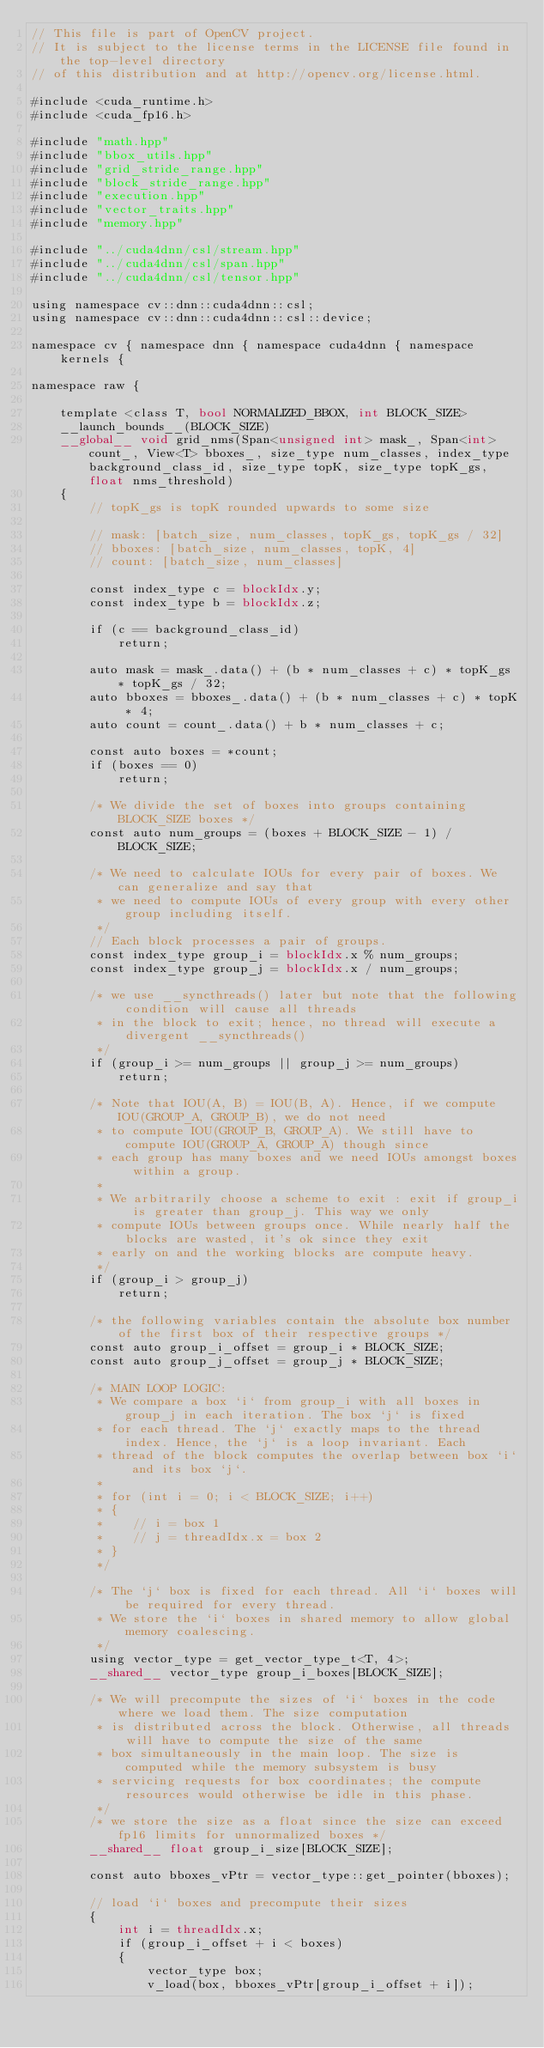Convert code to text. <code><loc_0><loc_0><loc_500><loc_500><_Cuda_>// This file is part of OpenCV project.
// It is subject to the license terms in the LICENSE file found in the top-level directory
// of this distribution and at http://opencv.org/license.html.

#include <cuda_runtime.h>
#include <cuda_fp16.h>

#include "math.hpp"
#include "bbox_utils.hpp"
#include "grid_stride_range.hpp"
#include "block_stride_range.hpp"
#include "execution.hpp"
#include "vector_traits.hpp"
#include "memory.hpp"

#include "../cuda4dnn/csl/stream.hpp"
#include "../cuda4dnn/csl/span.hpp"
#include "../cuda4dnn/csl/tensor.hpp"

using namespace cv::dnn::cuda4dnn::csl;
using namespace cv::dnn::cuda4dnn::csl::device;

namespace cv { namespace dnn { namespace cuda4dnn { namespace kernels {

namespace raw {

    template <class T, bool NORMALIZED_BBOX, int BLOCK_SIZE>
    __launch_bounds__(BLOCK_SIZE)
    __global__ void grid_nms(Span<unsigned int> mask_, Span<int> count_, View<T> bboxes_, size_type num_classes, index_type background_class_id, size_type topK, size_type topK_gs, float nms_threshold)
    {
        // topK_gs is topK rounded upwards to some size

        // mask: [batch_size, num_classes, topK_gs, topK_gs / 32]
        // bboxes: [batch_size, num_classes, topK, 4]
        // count: [batch_size, num_classes]

        const index_type c = blockIdx.y;
        const index_type b = blockIdx.z;

        if (c == background_class_id)
            return;

        auto mask = mask_.data() + (b * num_classes + c) * topK_gs * topK_gs / 32;
        auto bboxes = bboxes_.data() + (b * num_classes + c) * topK * 4;
        auto count = count_.data() + b * num_classes + c;

        const auto boxes = *count;
        if (boxes == 0)
            return;

        /* We divide the set of boxes into groups containing BLOCK_SIZE boxes */
        const auto num_groups = (boxes + BLOCK_SIZE - 1) / BLOCK_SIZE;

        /* We need to calculate IOUs for every pair of boxes. We can generalize and say that
         * we need to compute IOUs of every group with every other group including itself.
         */
        // Each block processes a pair of groups.
        const index_type group_i = blockIdx.x % num_groups;
        const index_type group_j = blockIdx.x / num_groups;

        /* we use __syncthreads() later but note that the following condition will cause all threads
         * in the block to exit; hence, no thread will execute a divergent __syncthreads()
         */
        if (group_i >= num_groups || group_j >= num_groups)
            return;

        /* Note that IOU(A, B) = IOU(B, A). Hence, if we compute IOU(GROUP_A, GROUP_B), we do not need
         * to compute IOU(GROUP_B, GROUP_A). We still have to compute IOU(GROUP_A, GROUP_A) though since
         * each group has many boxes and we need IOUs amongst boxes within a group.
         *
         * We arbitrarily choose a scheme to exit : exit if group_i is greater than group_j. This way we only
         * compute IOUs between groups once. While nearly half the blocks are wasted, it's ok since they exit
         * early on and the working blocks are compute heavy.
         */
        if (group_i > group_j)
            return;

        /* the following variables contain the absolute box number of the first box of their respective groups */
        const auto group_i_offset = group_i * BLOCK_SIZE;
        const auto group_j_offset = group_j * BLOCK_SIZE;

        /* MAIN LOOP LOGIC:
         * We compare a box `i` from group_i with all boxes in group_j in each iteration. The box `j` is fixed
         * for each thread. The `j` exactly maps to the thread index. Hence, the `j` is a loop invariant. Each
         * thread of the block computes the overlap between box `i` and its box `j`.
         *
         * for (int i = 0; i < BLOCK_SIZE; i++)
         * {
         *    // i = box 1
         *    // j = threadIdx.x = box 2
         * }
         */

        /* The `j` box is fixed for each thread. All `i` boxes will be required for every thread.
         * We store the `i` boxes in shared memory to allow global memory coalescing.
         */
        using vector_type = get_vector_type_t<T, 4>;
        __shared__ vector_type group_i_boxes[BLOCK_SIZE];

        /* We will precompute the sizes of `i` boxes in the code where we load them. The size computation
         * is distributed across the block. Otherwise, all threads will have to compute the size of the same
         * box simultaneously in the main loop. The size is computed while the memory subsystem is busy
         * servicing requests for box coordinates; the compute resources would otherwise be idle in this phase.
         */
        /* we store the size as a float since the size can exceed fp16 limits for unnormalized boxes */
        __shared__ float group_i_size[BLOCK_SIZE];

        const auto bboxes_vPtr = vector_type::get_pointer(bboxes);

        // load `i` boxes and precompute their sizes
        {
            int i = threadIdx.x;
            if (group_i_offset + i < boxes)
            {
                vector_type box;
                v_load(box, bboxes_vPtr[group_i_offset + i]);</code> 